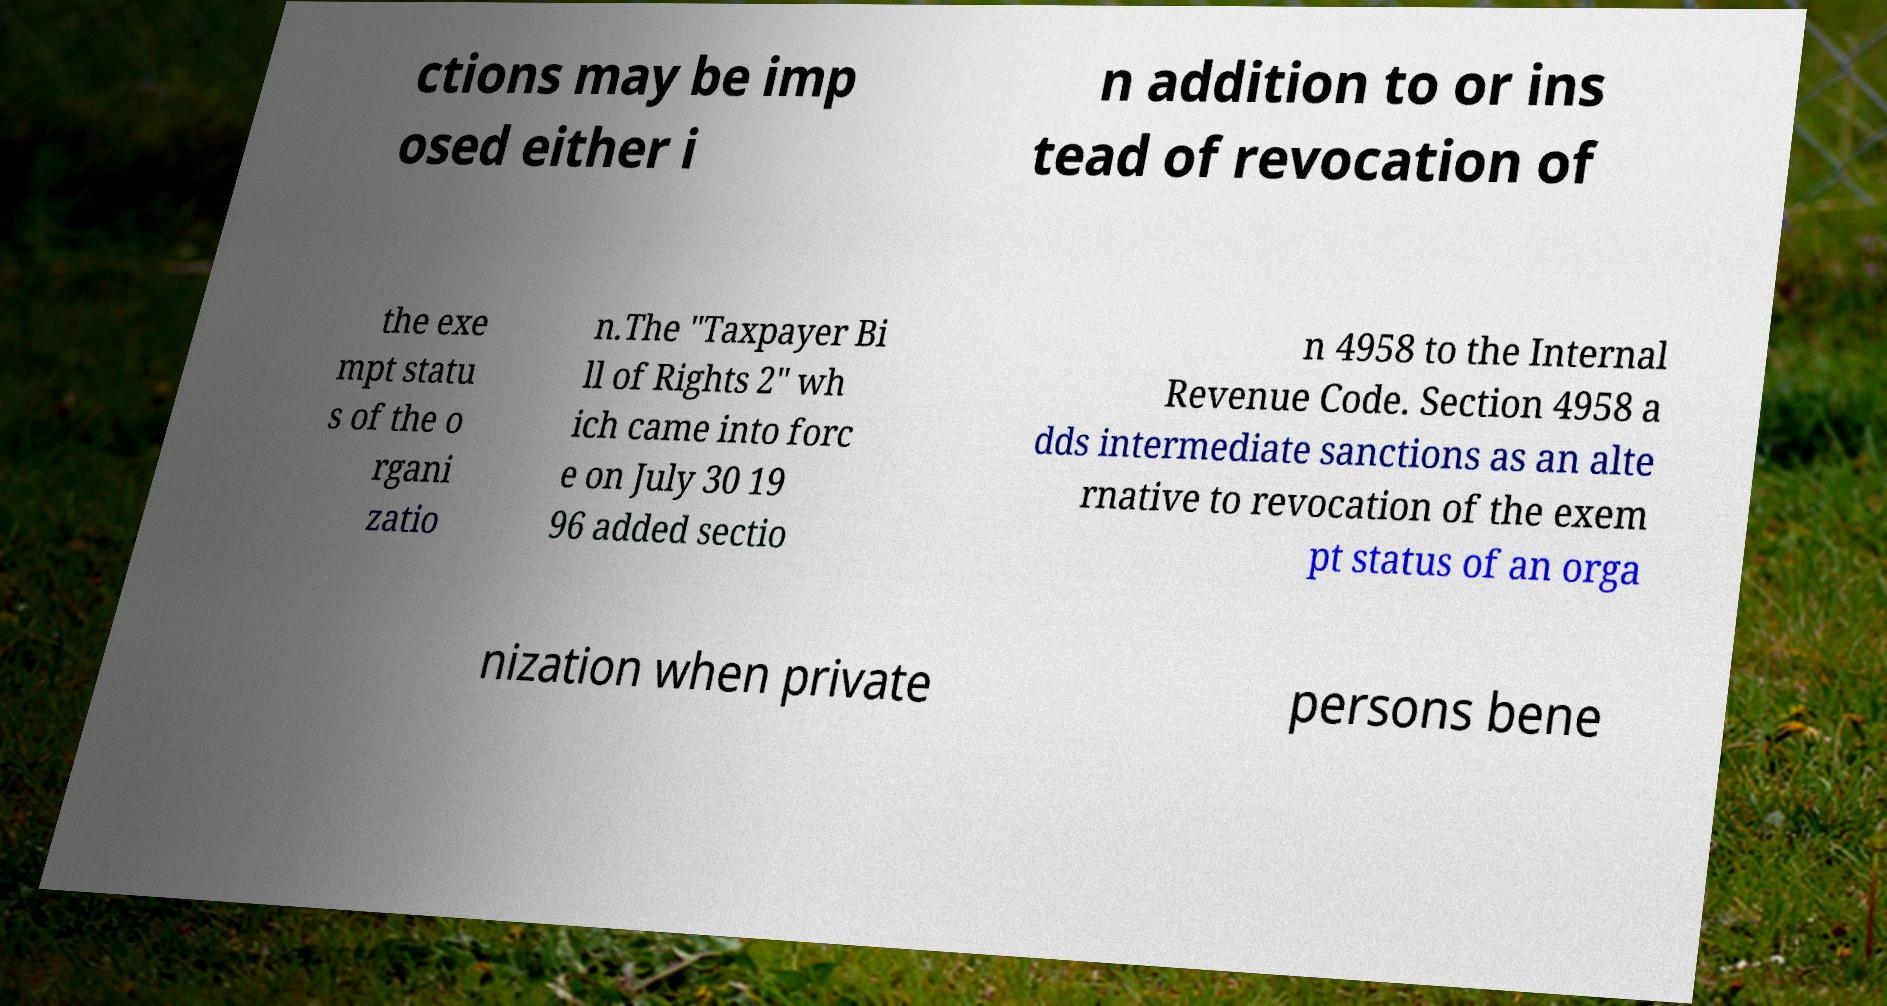Could you extract and type out the text from this image? ctions may be imp osed either i n addition to or ins tead of revocation of the exe mpt statu s of the o rgani zatio n.The "Taxpayer Bi ll of Rights 2" wh ich came into forc e on July 30 19 96 added sectio n 4958 to the Internal Revenue Code. Section 4958 a dds intermediate sanctions as an alte rnative to revocation of the exem pt status of an orga nization when private persons bene 